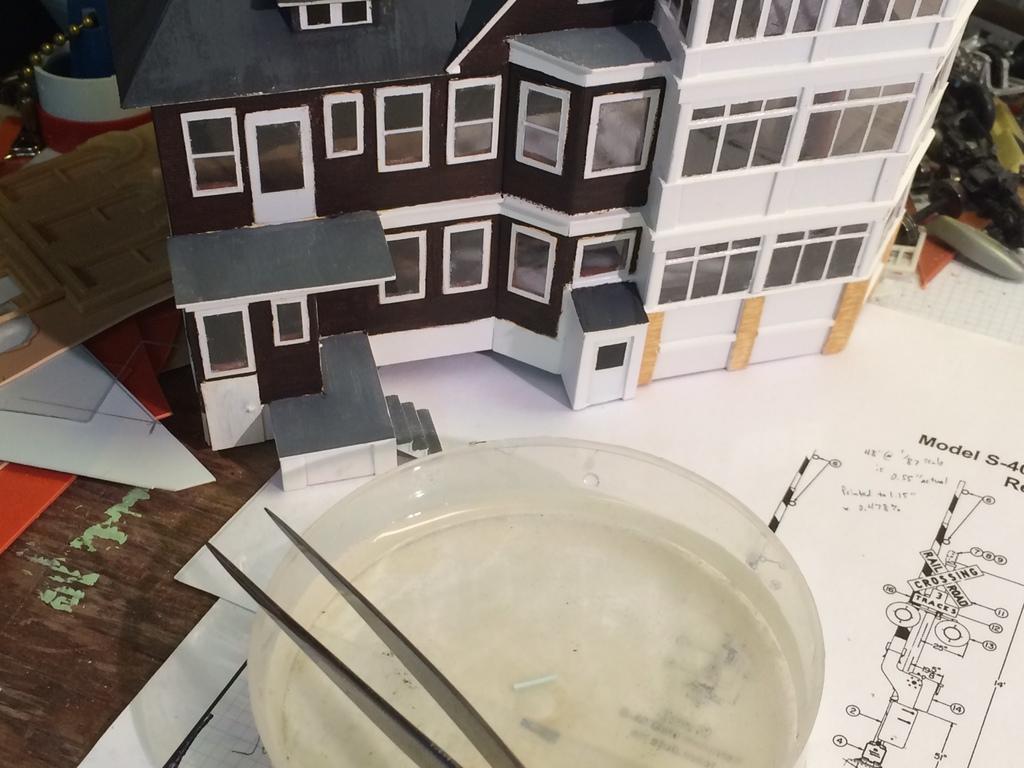How would you summarize this image in a sentence or two? In this image we can see the depiction of buildings. We can also see the text papers, bowl and some other objects on the table. 